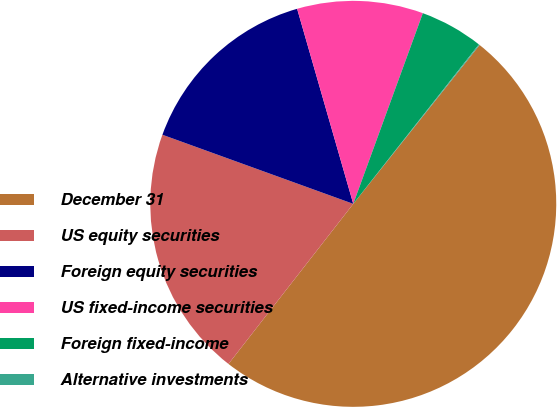Convert chart. <chart><loc_0><loc_0><loc_500><loc_500><pie_chart><fcel>December 31<fcel>US equity securities<fcel>Foreign equity securities<fcel>US fixed-income securities<fcel>Foreign fixed-income<fcel>Alternative investments<nl><fcel>49.85%<fcel>19.99%<fcel>15.01%<fcel>10.03%<fcel>5.05%<fcel>0.07%<nl></chart> 